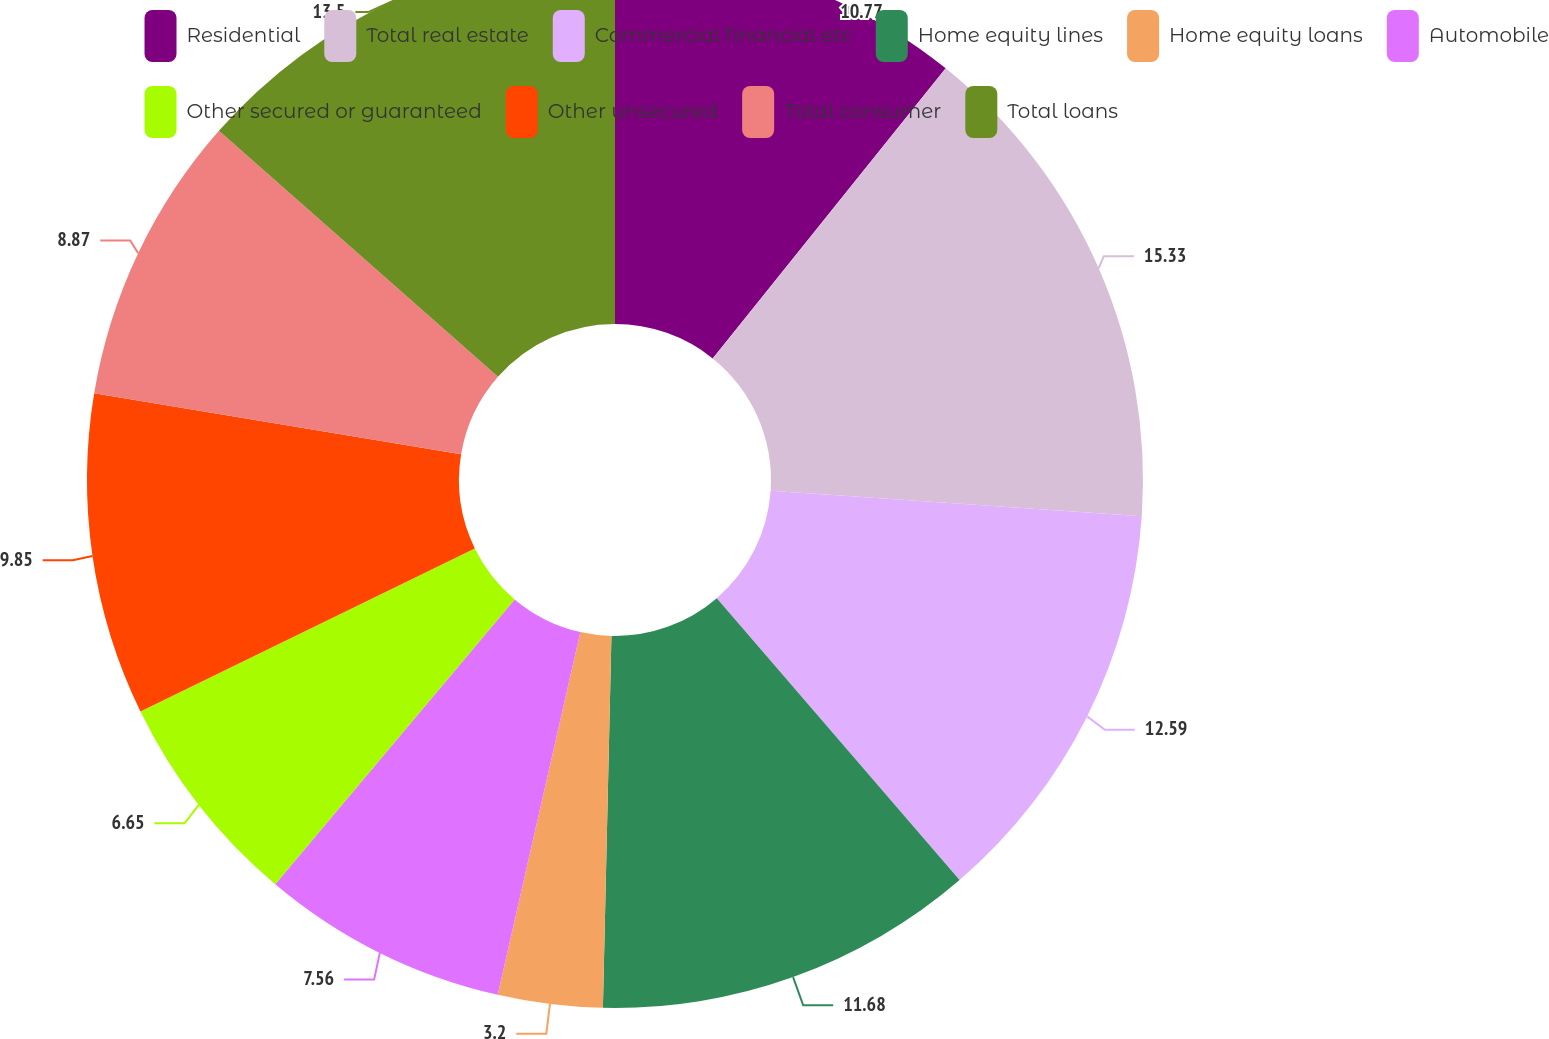Convert chart. <chart><loc_0><loc_0><loc_500><loc_500><pie_chart><fcel>Residential<fcel>Total real estate<fcel>Commercial financial etc<fcel>Home equity lines<fcel>Home equity loans<fcel>Automobile<fcel>Other secured or guaranteed<fcel>Other unsecured<fcel>Total consumer<fcel>Total loans<nl><fcel>10.77%<fcel>15.32%<fcel>12.59%<fcel>11.68%<fcel>3.2%<fcel>7.56%<fcel>6.65%<fcel>9.85%<fcel>8.87%<fcel>13.5%<nl></chart> 